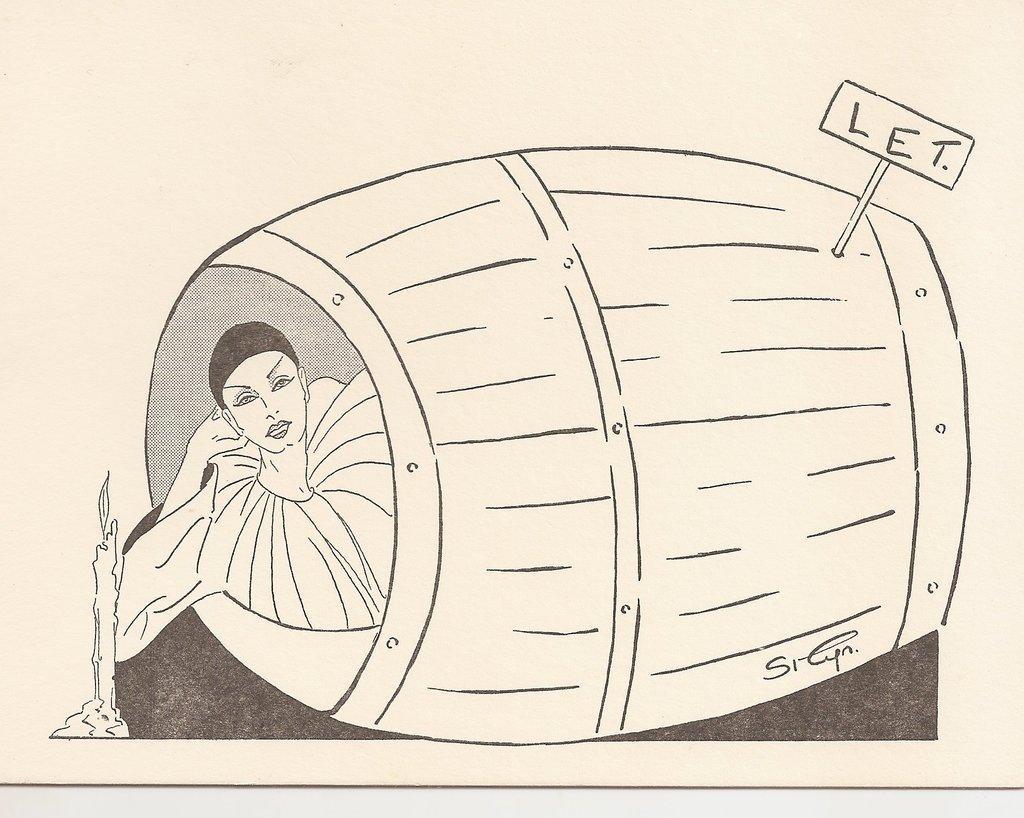How would you summarize this image in a sentence or two? In this image there is one picture of women as we can see at left side of this image and there is a drum image in middle of this image and there is a picture of a candle at left side of this image and there is some text written at top right corner of this image. 